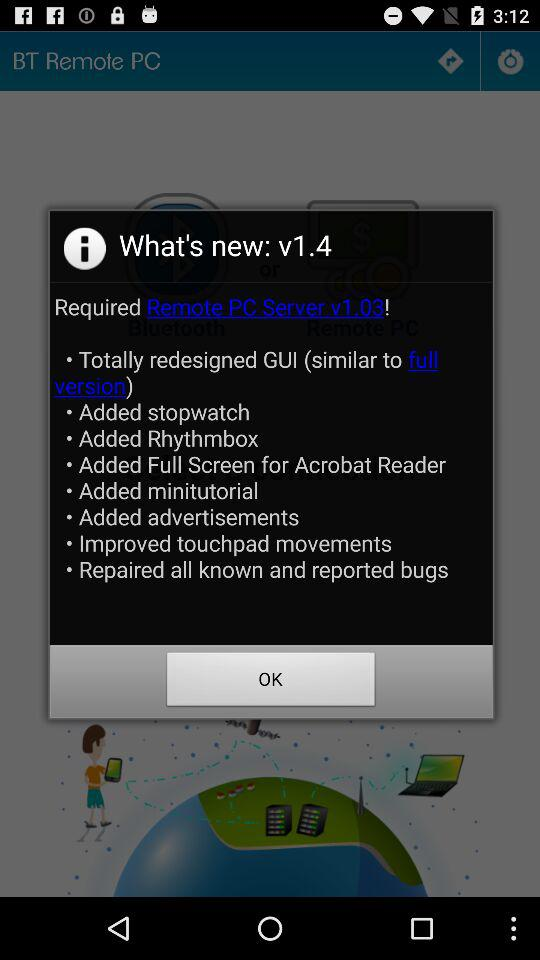What is the version of the application? The version of the application is v1.4. 